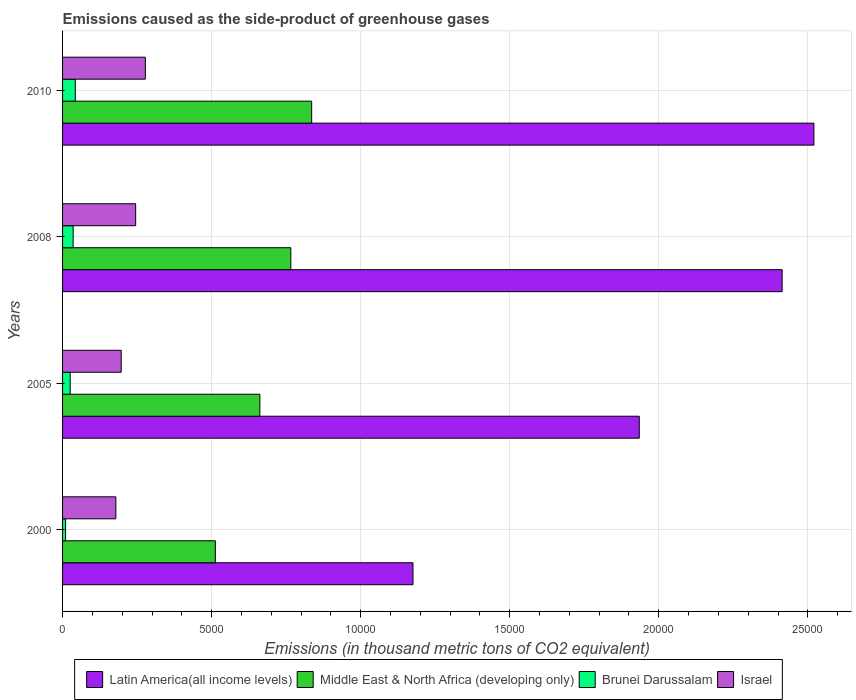Are the number of bars per tick equal to the number of legend labels?
Your answer should be compact. Yes. Are the number of bars on each tick of the Y-axis equal?
Your answer should be very brief. Yes. How many bars are there on the 3rd tick from the bottom?
Offer a very short reply. 4. What is the label of the 3rd group of bars from the top?
Offer a very short reply. 2005. What is the emissions caused as the side-product of greenhouse gases in Brunei Darussalam in 2005?
Keep it short and to the point. 255.6. Across all years, what is the maximum emissions caused as the side-product of greenhouse gases in Middle East & North Africa (developing only)?
Provide a succinct answer. 8356. Across all years, what is the minimum emissions caused as the side-product of greenhouse gases in Israel?
Your answer should be compact. 1787.6. In which year was the emissions caused as the side-product of greenhouse gases in Middle East & North Africa (developing only) maximum?
Provide a succinct answer. 2010. What is the total emissions caused as the side-product of greenhouse gases in Latin America(all income levels) in the graph?
Offer a terse response. 8.04e+04. What is the difference between the emissions caused as the side-product of greenhouse gases in Latin America(all income levels) in 2000 and that in 2010?
Give a very brief answer. -1.34e+04. What is the difference between the emissions caused as the side-product of greenhouse gases in Middle East & North Africa (developing only) in 2000 and the emissions caused as the side-product of greenhouse gases in Latin America(all income levels) in 2008?
Make the answer very short. -1.90e+04. What is the average emissions caused as the side-product of greenhouse gases in Israel per year?
Provide a short and direct response. 2246.03. In the year 2008, what is the difference between the emissions caused as the side-product of greenhouse gases in Israel and emissions caused as the side-product of greenhouse gases in Middle East & North Africa (developing only)?
Offer a terse response. -5205.1. What is the ratio of the emissions caused as the side-product of greenhouse gases in Latin America(all income levels) in 2005 to that in 2008?
Your response must be concise. 0.8. Is the emissions caused as the side-product of greenhouse gases in Latin America(all income levels) in 2005 less than that in 2010?
Provide a short and direct response. Yes. What is the difference between the highest and the second highest emissions caused as the side-product of greenhouse gases in Brunei Darussalam?
Ensure brevity in your answer.  72.1. What is the difference between the highest and the lowest emissions caused as the side-product of greenhouse gases in Latin America(all income levels)?
Your answer should be compact. 1.34e+04. Is the sum of the emissions caused as the side-product of greenhouse gases in Middle East & North Africa (developing only) in 2008 and 2010 greater than the maximum emissions caused as the side-product of greenhouse gases in Latin America(all income levels) across all years?
Give a very brief answer. No. What does the 4th bar from the top in 2008 represents?
Your answer should be compact. Latin America(all income levels). What does the 2nd bar from the bottom in 2008 represents?
Make the answer very short. Middle East & North Africa (developing only). Is it the case that in every year, the sum of the emissions caused as the side-product of greenhouse gases in Brunei Darussalam and emissions caused as the side-product of greenhouse gases in Israel is greater than the emissions caused as the side-product of greenhouse gases in Middle East & North Africa (developing only)?
Your answer should be compact. No. Are all the bars in the graph horizontal?
Provide a succinct answer. Yes. What is the difference between two consecutive major ticks on the X-axis?
Make the answer very short. 5000. Are the values on the major ticks of X-axis written in scientific E-notation?
Make the answer very short. No. How many legend labels are there?
Provide a short and direct response. 4. How are the legend labels stacked?
Your answer should be very brief. Horizontal. What is the title of the graph?
Your response must be concise. Emissions caused as the side-product of greenhouse gases. What is the label or title of the X-axis?
Ensure brevity in your answer.  Emissions (in thousand metric tons of CO2 equivalent). What is the label or title of the Y-axis?
Your answer should be compact. Years. What is the Emissions (in thousand metric tons of CO2 equivalent) of Latin America(all income levels) in 2000?
Give a very brief answer. 1.18e+04. What is the Emissions (in thousand metric tons of CO2 equivalent) in Middle East & North Africa (developing only) in 2000?
Offer a very short reply. 5124.9. What is the Emissions (in thousand metric tons of CO2 equivalent) of Brunei Darussalam in 2000?
Provide a succinct answer. 100.7. What is the Emissions (in thousand metric tons of CO2 equivalent) in Israel in 2000?
Keep it short and to the point. 1787.6. What is the Emissions (in thousand metric tons of CO2 equivalent) of Latin America(all income levels) in 2005?
Provide a short and direct response. 1.93e+04. What is the Emissions (in thousand metric tons of CO2 equivalent) in Middle East & North Africa (developing only) in 2005?
Provide a succinct answer. 6617.8. What is the Emissions (in thousand metric tons of CO2 equivalent) of Brunei Darussalam in 2005?
Keep it short and to the point. 255.6. What is the Emissions (in thousand metric tons of CO2 equivalent) of Israel in 2005?
Your response must be concise. 1967.4. What is the Emissions (in thousand metric tons of CO2 equivalent) in Latin America(all income levels) in 2008?
Your answer should be compact. 2.41e+04. What is the Emissions (in thousand metric tons of CO2 equivalent) in Middle East & North Africa (developing only) in 2008?
Make the answer very short. 7657.2. What is the Emissions (in thousand metric tons of CO2 equivalent) in Brunei Darussalam in 2008?
Your response must be concise. 354.9. What is the Emissions (in thousand metric tons of CO2 equivalent) in Israel in 2008?
Keep it short and to the point. 2452.1. What is the Emissions (in thousand metric tons of CO2 equivalent) in Latin America(all income levels) in 2010?
Provide a short and direct response. 2.52e+04. What is the Emissions (in thousand metric tons of CO2 equivalent) of Middle East & North Africa (developing only) in 2010?
Your answer should be very brief. 8356. What is the Emissions (in thousand metric tons of CO2 equivalent) in Brunei Darussalam in 2010?
Offer a terse response. 427. What is the Emissions (in thousand metric tons of CO2 equivalent) of Israel in 2010?
Ensure brevity in your answer.  2777. Across all years, what is the maximum Emissions (in thousand metric tons of CO2 equivalent) of Latin America(all income levels)?
Give a very brief answer. 2.52e+04. Across all years, what is the maximum Emissions (in thousand metric tons of CO2 equivalent) of Middle East & North Africa (developing only)?
Offer a very short reply. 8356. Across all years, what is the maximum Emissions (in thousand metric tons of CO2 equivalent) of Brunei Darussalam?
Your answer should be very brief. 427. Across all years, what is the maximum Emissions (in thousand metric tons of CO2 equivalent) of Israel?
Ensure brevity in your answer.  2777. Across all years, what is the minimum Emissions (in thousand metric tons of CO2 equivalent) in Latin America(all income levels)?
Your answer should be compact. 1.18e+04. Across all years, what is the minimum Emissions (in thousand metric tons of CO2 equivalent) of Middle East & North Africa (developing only)?
Your response must be concise. 5124.9. Across all years, what is the minimum Emissions (in thousand metric tons of CO2 equivalent) of Brunei Darussalam?
Make the answer very short. 100.7. Across all years, what is the minimum Emissions (in thousand metric tons of CO2 equivalent) in Israel?
Your answer should be very brief. 1787.6. What is the total Emissions (in thousand metric tons of CO2 equivalent) of Latin America(all income levels) in the graph?
Provide a short and direct response. 8.04e+04. What is the total Emissions (in thousand metric tons of CO2 equivalent) of Middle East & North Africa (developing only) in the graph?
Offer a terse response. 2.78e+04. What is the total Emissions (in thousand metric tons of CO2 equivalent) in Brunei Darussalam in the graph?
Make the answer very short. 1138.2. What is the total Emissions (in thousand metric tons of CO2 equivalent) of Israel in the graph?
Keep it short and to the point. 8984.1. What is the difference between the Emissions (in thousand metric tons of CO2 equivalent) in Latin America(all income levels) in 2000 and that in 2005?
Provide a succinct answer. -7590.8. What is the difference between the Emissions (in thousand metric tons of CO2 equivalent) of Middle East & North Africa (developing only) in 2000 and that in 2005?
Your answer should be very brief. -1492.9. What is the difference between the Emissions (in thousand metric tons of CO2 equivalent) in Brunei Darussalam in 2000 and that in 2005?
Make the answer very short. -154.9. What is the difference between the Emissions (in thousand metric tons of CO2 equivalent) of Israel in 2000 and that in 2005?
Your answer should be compact. -179.8. What is the difference between the Emissions (in thousand metric tons of CO2 equivalent) of Latin America(all income levels) in 2000 and that in 2008?
Provide a succinct answer. -1.24e+04. What is the difference between the Emissions (in thousand metric tons of CO2 equivalent) in Middle East & North Africa (developing only) in 2000 and that in 2008?
Offer a terse response. -2532.3. What is the difference between the Emissions (in thousand metric tons of CO2 equivalent) in Brunei Darussalam in 2000 and that in 2008?
Offer a terse response. -254.2. What is the difference between the Emissions (in thousand metric tons of CO2 equivalent) in Israel in 2000 and that in 2008?
Keep it short and to the point. -664.5. What is the difference between the Emissions (in thousand metric tons of CO2 equivalent) of Latin America(all income levels) in 2000 and that in 2010?
Your answer should be very brief. -1.34e+04. What is the difference between the Emissions (in thousand metric tons of CO2 equivalent) in Middle East & North Africa (developing only) in 2000 and that in 2010?
Make the answer very short. -3231.1. What is the difference between the Emissions (in thousand metric tons of CO2 equivalent) of Brunei Darussalam in 2000 and that in 2010?
Your response must be concise. -326.3. What is the difference between the Emissions (in thousand metric tons of CO2 equivalent) in Israel in 2000 and that in 2010?
Give a very brief answer. -989.4. What is the difference between the Emissions (in thousand metric tons of CO2 equivalent) of Latin America(all income levels) in 2005 and that in 2008?
Offer a terse response. -4793.3. What is the difference between the Emissions (in thousand metric tons of CO2 equivalent) of Middle East & North Africa (developing only) in 2005 and that in 2008?
Make the answer very short. -1039.4. What is the difference between the Emissions (in thousand metric tons of CO2 equivalent) in Brunei Darussalam in 2005 and that in 2008?
Your answer should be very brief. -99.3. What is the difference between the Emissions (in thousand metric tons of CO2 equivalent) of Israel in 2005 and that in 2008?
Your response must be concise. -484.7. What is the difference between the Emissions (in thousand metric tons of CO2 equivalent) of Latin America(all income levels) in 2005 and that in 2010?
Give a very brief answer. -5858.9. What is the difference between the Emissions (in thousand metric tons of CO2 equivalent) in Middle East & North Africa (developing only) in 2005 and that in 2010?
Your answer should be compact. -1738.2. What is the difference between the Emissions (in thousand metric tons of CO2 equivalent) of Brunei Darussalam in 2005 and that in 2010?
Give a very brief answer. -171.4. What is the difference between the Emissions (in thousand metric tons of CO2 equivalent) in Israel in 2005 and that in 2010?
Give a very brief answer. -809.6. What is the difference between the Emissions (in thousand metric tons of CO2 equivalent) in Latin America(all income levels) in 2008 and that in 2010?
Your response must be concise. -1065.6. What is the difference between the Emissions (in thousand metric tons of CO2 equivalent) in Middle East & North Africa (developing only) in 2008 and that in 2010?
Provide a short and direct response. -698.8. What is the difference between the Emissions (in thousand metric tons of CO2 equivalent) of Brunei Darussalam in 2008 and that in 2010?
Ensure brevity in your answer.  -72.1. What is the difference between the Emissions (in thousand metric tons of CO2 equivalent) in Israel in 2008 and that in 2010?
Give a very brief answer. -324.9. What is the difference between the Emissions (in thousand metric tons of CO2 equivalent) of Latin America(all income levels) in 2000 and the Emissions (in thousand metric tons of CO2 equivalent) of Middle East & North Africa (developing only) in 2005?
Provide a short and direct response. 5137.5. What is the difference between the Emissions (in thousand metric tons of CO2 equivalent) in Latin America(all income levels) in 2000 and the Emissions (in thousand metric tons of CO2 equivalent) in Brunei Darussalam in 2005?
Offer a terse response. 1.15e+04. What is the difference between the Emissions (in thousand metric tons of CO2 equivalent) in Latin America(all income levels) in 2000 and the Emissions (in thousand metric tons of CO2 equivalent) in Israel in 2005?
Keep it short and to the point. 9787.9. What is the difference between the Emissions (in thousand metric tons of CO2 equivalent) in Middle East & North Africa (developing only) in 2000 and the Emissions (in thousand metric tons of CO2 equivalent) in Brunei Darussalam in 2005?
Make the answer very short. 4869.3. What is the difference between the Emissions (in thousand metric tons of CO2 equivalent) in Middle East & North Africa (developing only) in 2000 and the Emissions (in thousand metric tons of CO2 equivalent) in Israel in 2005?
Keep it short and to the point. 3157.5. What is the difference between the Emissions (in thousand metric tons of CO2 equivalent) in Brunei Darussalam in 2000 and the Emissions (in thousand metric tons of CO2 equivalent) in Israel in 2005?
Offer a terse response. -1866.7. What is the difference between the Emissions (in thousand metric tons of CO2 equivalent) in Latin America(all income levels) in 2000 and the Emissions (in thousand metric tons of CO2 equivalent) in Middle East & North Africa (developing only) in 2008?
Your answer should be compact. 4098.1. What is the difference between the Emissions (in thousand metric tons of CO2 equivalent) in Latin America(all income levels) in 2000 and the Emissions (in thousand metric tons of CO2 equivalent) in Brunei Darussalam in 2008?
Provide a succinct answer. 1.14e+04. What is the difference between the Emissions (in thousand metric tons of CO2 equivalent) in Latin America(all income levels) in 2000 and the Emissions (in thousand metric tons of CO2 equivalent) in Israel in 2008?
Your answer should be compact. 9303.2. What is the difference between the Emissions (in thousand metric tons of CO2 equivalent) in Middle East & North Africa (developing only) in 2000 and the Emissions (in thousand metric tons of CO2 equivalent) in Brunei Darussalam in 2008?
Provide a short and direct response. 4770. What is the difference between the Emissions (in thousand metric tons of CO2 equivalent) of Middle East & North Africa (developing only) in 2000 and the Emissions (in thousand metric tons of CO2 equivalent) of Israel in 2008?
Give a very brief answer. 2672.8. What is the difference between the Emissions (in thousand metric tons of CO2 equivalent) in Brunei Darussalam in 2000 and the Emissions (in thousand metric tons of CO2 equivalent) in Israel in 2008?
Ensure brevity in your answer.  -2351.4. What is the difference between the Emissions (in thousand metric tons of CO2 equivalent) of Latin America(all income levels) in 2000 and the Emissions (in thousand metric tons of CO2 equivalent) of Middle East & North Africa (developing only) in 2010?
Your answer should be compact. 3399.3. What is the difference between the Emissions (in thousand metric tons of CO2 equivalent) of Latin America(all income levels) in 2000 and the Emissions (in thousand metric tons of CO2 equivalent) of Brunei Darussalam in 2010?
Offer a very short reply. 1.13e+04. What is the difference between the Emissions (in thousand metric tons of CO2 equivalent) of Latin America(all income levels) in 2000 and the Emissions (in thousand metric tons of CO2 equivalent) of Israel in 2010?
Offer a very short reply. 8978.3. What is the difference between the Emissions (in thousand metric tons of CO2 equivalent) in Middle East & North Africa (developing only) in 2000 and the Emissions (in thousand metric tons of CO2 equivalent) in Brunei Darussalam in 2010?
Make the answer very short. 4697.9. What is the difference between the Emissions (in thousand metric tons of CO2 equivalent) of Middle East & North Africa (developing only) in 2000 and the Emissions (in thousand metric tons of CO2 equivalent) of Israel in 2010?
Your answer should be very brief. 2347.9. What is the difference between the Emissions (in thousand metric tons of CO2 equivalent) of Brunei Darussalam in 2000 and the Emissions (in thousand metric tons of CO2 equivalent) of Israel in 2010?
Offer a terse response. -2676.3. What is the difference between the Emissions (in thousand metric tons of CO2 equivalent) of Latin America(all income levels) in 2005 and the Emissions (in thousand metric tons of CO2 equivalent) of Middle East & North Africa (developing only) in 2008?
Ensure brevity in your answer.  1.17e+04. What is the difference between the Emissions (in thousand metric tons of CO2 equivalent) in Latin America(all income levels) in 2005 and the Emissions (in thousand metric tons of CO2 equivalent) in Brunei Darussalam in 2008?
Your answer should be compact. 1.90e+04. What is the difference between the Emissions (in thousand metric tons of CO2 equivalent) in Latin America(all income levels) in 2005 and the Emissions (in thousand metric tons of CO2 equivalent) in Israel in 2008?
Your response must be concise. 1.69e+04. What is the difference between the Emissions (in thousand metric tons of CO2 equivalent) of Middle East & North Africa (developing only) in 2005 and the Emissions (in thousand metric tons of CO2 equivalent) of Brunei Darussalam in 2008?
Your answer should be very brief. 6262.9. What is the difference between the Emissions (in thousand metric tons of CO2 equivalent) in Middle East & North Africa (developing only) in 2005 and the Emissions (in thousand metric tons of CO2 equivalent) in Israel in 2008?
Your answer should be very brief. 4165.7. What is the difference between the Emissions (in thousand metric tons of CO2 equivalent) of Brunei Darussalam in 2005 and the Emissions (in thousand metric tons of CO2 equivalent) of Israel in 2008?
Make the answer very short. -2196.5. What is the difference between the Emissions (in thousand metric tons of CO2 equivalent) in Latin America(all income levels) in 2005 and the Emissions (in thousand metric tons of CO2 equivalent) in Middle East & North Africa (developing only) in 2010?
Your answer should be very brief. 1.10e+04. What is the difference between the Emissions (in thousand metric tons of CO2 equivalent) in Latin America(all income levels) in 2005 and the Emissions (in thousand metric tons of CO2 equivalent) in Brunei Darussalam in 2010?
Offer a very short reply. 1.89e+04. What is the difference between the Emissions (in thousand metric tons of CO2 equivalent) of Latin America(all income levels) in 2005 and the Emissions (in thousand metric tons of CO2 equivalent) of Israel in 2010?
Keep it short and to the point. 1.66e+04. What is the difference between the Emissions (in thousand metric tons of CO2 equivalent) of Middle East & North Africa (developing only) in 2005 and the Emissions (in thousand metric tons of CO2 equivalent) of Brunei Darussalam in 2010?
Provide a short and direct response. 6190.8. What is the difference between the Emissions (in thousand metric tons of CO2 equivalent) of Middle East & North Africa (developing only) in 2005 and the Emissions (in thousand metric tons of CO2 equivalent) of Israel in 2010?
Make the answer very short. 3840.8. What is the difference between the Emissions (in thousand metric tons of CO2 equivalent) in Brunei Darussalam in 2005 and the Emissions (in thousand metric tons of CO2 equivalent) in Israel in 2010?
Give a very brief answer. -2521.4. What is the difference between the Emissions (in thousand metric tons of CO2 equivalent) in Latin America(all income levels) in 2008 and the Emissions (in thousand metric tons of CO2 equivalent) in Middle East & North Africa (developing only) in 2010?
Give a very brief answer. 1.58e+04. What is the difference between the Emissions (in thousand metric tons of CO2 equivalent) of Latin America(all income levels) in 2008 and the Emissions (in thousand metric tons of CO2 equivalent) of Brunei Darussalam in 2010?
Offer a very short reply. 2.37e+04. What is the difference between the Emissions (in thousand metric tons of CO2 equivalent) in Latin America(all income levels) in 2008 and the Emissions (in thousand metric tons of CO2 equivalent) in Israel in 2010?
Ensure brevity in your answer.  2.14e+04. What is the difference between the Emissions (in thousand metric tons of CO2 equivalent) of Middle East & North Africa (developing only) in 2008 and the Emissions (in thousand metric tons of CO2 equivalent) of Brunei Darussalam in 2010?
Your response must be concise. 7230.2. What is the difference between the Emissions (in thousand metric tons of CO2 equivalent) in Middle East & North Africa (developing only) in 2008 and the Emissions (in thousand metric tons of CO2 equivalent) in Israel in 2010?
Provide a short and direct response. 4880.2. What is the difference between the Emissions (in thousand metric tons of CO2 equivalent) of Brunei Darussalam in 2008 and the Emissions (in thousand metric tons of CO2 equivalent) of Israel in 2010?
Your response must be concise. -2422.1. What is the average Emissions (in thousand metric tons of CO2 equivalent) in Latin America(all income levels) per year?
Keep it short and to the point. 2.01e+04. What is the average Emissions (in thousand metric tons of CO2 equivalent) in Middle East & North Africa (developing only) per year?
Offer a very short reply. 6938.98. What is the average Emissions (in thousand metric tons of CO2 equivalent) of Brunei Darussalam per year?
Provide a short and direct response. 284.55. What is the average Emissions (in thousand metric tons of CO2 equivalent) in Israel per year?
Ensure brevity in your answer.  2246.03. In the year 2000, what is the difference between the Emissions (in thousand metric tons of CO2 equivalent) of Latin America(all income levels) and Emissions (in thousand metric tons of CO2 equivalent) of Middle East & North Africa (developing only)?
Make the answer very short. 6630.4. In the year 2000, what is the difference between the Emissions (in thousand metric tons of CO2 equivalent) in Latin America(all income levels) and Emissions (in thousand metric tons of CO2 equivalent) in Brunei Darussalam?
Offer a very short reply. 1.17e+04. In the year 2000, what is the difference between the Emissions (in thousand metric tons of CO2 equivalent) in Latin America(all income levels) and Emissions (in thousand metric tons of CO2 equivalent) in Israel?
Make the answer very short. 9967.7. In the year 2000, what is the difference between the Emissions (in thousand metric tons of CO2 equivalent) in Middle East & North Africa (developing only) and Emissions (in thousand metric tons of CO2 equivalent) in Brunei Darussalam?
Offer a very short reply. 5024.2. In the year 2000, what is the difference between the Emissions (in thousand metric tons of CO2 equivalent) of Middle East & North Africa (developing only) and Emissions (in thousand metric tons of CO2 equivalent) of Israel?
Your response must be concise. 3337.3. In the year 2000, what is the difference between the Emissions (in thousand metric tons of CO2 equivalent) in Brunei Darussalam and Emissions (in thousand metric tons of CO2 equivalent) in Israel?
Your answer should be very brief. -1686.9. In the year 2005, what is the difference between the Emissions (in thousand metric tons of CO2 equivalent) of Latin America(all income levels) and Emissions (in thousand metric tons of CO2 equivalent) of Middle East & North Africa (developing only)?
Keep it short and to the point. 1.27e+04. In the year 2005, what is the difference between the Emissions (in thousand metric tons of CO2 equivalent) in Latin America(all income levels) and Emissions (in thousand metric tons of CO2 equivalent) in Brunei Darussalam?
Ensure brevity in your answer.  1.91e+04. In the year 2005, what is the difference between the Emissions (in thousand metric tons of CO2 equivalent) in Latin America(all income levels) and Emissions (in thousand metric tons of CO2 equivalent) in Israel?
Offer a terse response. 1.74e+04. In the year 2005, what is the difference between the Emissions (in thousand metric tons of CO2 equivalent) in Middle East & North Africa (developing only) and Emissions (in thousand metric tons of CO2 equivalent) in Brunei Darussalam?
Ensure brevity in your answer.  6362.2. In the year 2005, what is the difference between the Emissions (in thousand metric tons of CO2 equivalent) of Middle East & North Africa (developing only) and Emissions (in thousand metric tons of CO2 equivalent) of Israel?
Ensure brevity in your answer.  4650.4. In the year 2005, what is the difference between the Emissions (in thousand metric tons of CO2 equivalent) of Brunei Darussalam and Emissions (in thousand metric tons of CO2 equivalent) of Israel?
Provide a succinct answer. -1711.8. In the year 2008, what is the difference between the Emissions (in thousand metric tons of CO2 equivalent) in Latin America(all income levels) and Emissions (in thousand metric tons of CO2 equivalent) in Middle East & North Africa (developing only)?
Keep it short and to the point. 1.65e+04. In the year 2008, what is the difference between the Emissions (in thousand metric tons of CO2 equivalent) in Latin America(all income levels) and Emissions (in thousand metric tons of CO2 equivalent) in Brunei Darussalam?
Provide a succinct answer. 2.38e+04. In the year 2008, what is the difference between the Emissions (in thousand metric tons of CO2 equivalent) in Latin America(all income levels) and Emissions (in thousand metric tons of CO2 equivalent) in Israel?
Your answer should be very brief. 2.17e+04. In the year 2008, what is the difference between the Emissions (in thousand metric tons of CO2 equivalent) of Middle East & North Africa (developing only) and Emissions (in thousand metric tons of CO2 equivalent) of Brunei Darussalam?
Ensure brevity in your answer.  7302.3. In the year 2008, what is the difference between the Emissions (in thousand metric tons of CO2 equivalent) of Middle East & North Africa (developing only) and Emissions (in thousand metric tons of CO2 equivalent) of Israel?
Make the answer very short. 5205.1. In the year 2008, what is the difference between the Emissions (in thousand metric tons of CO2 equivalent) of Brunei Darussalam and Emissions (in thousand metric tons of CO2 equivalent) of Israel?
Keep it short and to the point. -2097.2. In the year 2010, what is the difference between the Emissions (in thousand metric tons of CO2 equivalent) in Latin America(all income levels) and Emissions (in thousand metric tons of CO2 equivalent) in Middle East & North Africa (developing only)?
Ensure brevity in your answer.  1.68e+04. In the year 2010, what is the difference between the Emissions (in thousand metric tons of CO2 equivalent) in Latin America(all income levels) and Emissions (in thousand metric tons of CO2 equivalent) in Brunei Darussalam?
Give a very brief answer. 2.48e+04. In the year 2010, what is the difference between the Emissions (in thousand metric tons of CO2 equivalent) of Latin America(all income levels) and Emissions (in thousand metric tons of CO2 equivalent) of Israel?
Offer a very short reply. 2.24e+04. In the year 2010, what is the difference between the Emissions (in thousand metric tons of CO2 equivalent) of Middle East & North Africa (developing only) and Emissions (in thousand metric tons of CO2 equivalent) of Brunei Darussalam?
Ensure brevity in your answer.  7929. In the year 2010, what is the difference between the Emissions (in thousand metric tons of CO2 equivalent) in Middle East & North Africa (developing only) and Emissions (in thousand metric tons of CO2 equivalent) in Israel?
Your answer should be very brief. 5579. In the year 2010, what is the difference between the Emissions (in thousand metric tons of CO2 equivalent) in Brunei Darussalam and Emissions (in thousand metric tons of CO2 equivalent) in Israel?
Your response must be concise. -2350. What is the ratio of the Emissions (in thousand metric tons of CO2 equivalent) of Latin America(all income levels) in 2000 to that in 2005?
Provide a succinct answer. 0.61. What is the ratio of the Emissions (in thousand metric tons of CO2 equivalent) in Middle East & North Africa (developing only) in 2000 to that in 2005?
Your answer should be compact. 0.77. What is the ratio of the Emissions (in thousand metric tons of CO2 equivalent) in Brunei Darussalam in 2000 to that in 2005?
Offer a very short reply. 0.39. What is the ratio of the Emissions (in thousand metric tons of CO2 equivalent) in Israel in 2000 to that in 2005?
Provide a short and direct response. 0.91. What is the ratio of the Emissions (in thousand metric tons of CO2 equivalent) of Latin America(all income levels) in 2000 to that in 2008?
Give a very brief answer. 0.49. What is the ratio of the Emissions (in thousand metric tons of CO2 equivalent) in Middle East & North Africa (developing only) in 2000 to that in 2008?
Offer a terse response. 0.67. What is the ratio of the Emissions (in thousand metric tons of CO2 equivalent) in Brunei Darussalam in 2000 to that in 2008?
Provide a succinct answer. 0.28. What is the ratio of the Emissions (in thousand metric tons of CO2 equivalent) in Israel in 2000 to that in 2008?
Your answer should be very brief. 0.73. What is the ratio of the Emissions (in thousand metric tons of CO2 equivalent) in Latin America(all income levels) in 2000 to that in 2010?
Give a very brief answer. 0.47. What is the ratio of the Emissions (in thousand metric tons of CO2 equivalent) in Middle East & North Africa (developing only) in 2000 to that in 2010?
Give a very brief answer. 0.61. What is the ratio of the Emissions (in thousand metric tons of CO2 equivalent) in Brunei Darussalam in 2000 to that in 2010?
Your response must be concise. 0.24. What is the ratio of the Emissions (in thousand metric tons of CO2 equivalent) of Israel in 2000 to that in 2010?
Provide a short and direct response. 0.64. What is the ratio of the Emissions (in thousand metric tons of CO2 equivalent) of Latin America(all income levels) in 2005 to that in 2008?
Keep it short and to the point. 0.8. What is the ratio of the Emissions (in thousand metric tons of CO2 equivalent) of Middle East & North Africa (developing only) in 2005 to that in 2008?
Give a very brief answer. 0.86. What is the ratio of the Emissions (in thousand metric tons of CO2 equivalent) in Brunei Darussalam in 2005 to that in 2008?
Ensure brevity in your answer.  0.72. What is the ratio of the Emissions (in thousand metric tons of CO2 equivalent) of Israel in 2005 to that in 2008?
Ensure brevity in your answer.  0.8. What is the ratio of the Emissions (in thousand metric tons of CO2 equivalent) in Latin America(all income levels) in 2005 to that in 2010?
Give a very brief answer. 0.77. What is the ratio of the Emissions (in thousand metric tons of CO2 equivalent) in Middle East & North Africa (developing only) in 2005 to that in 2010?
Provide a succinct answer. 0.79. What is the ratio of the Emissions (in thousand metric tons of CO2 equivalent) of Brunei Darussalam in 2005 to that in 2010?
Your answer should be compact. 0.6. What is the ratio of the Emissions (in thousand metric tons of CO2 equivalent) of Israel in 2005 to that in 2010?
Ensure brevity in your answer.  0.71. What is the ratio of the Emissions (in thousand metric tons of CO2 equivalent) in Latin America(all income levels) in 2008 to that in 2010?
Provide a short and direct response. 0.96. What is the ratio of the Emissions (in thousand metric tons of CO2 equivalent) of Middle East & North Africa (developing only) in 2008 to that in 2010?
Your answer should be very brief. 0.92. What is the ratio of the Emissions (in thousand metric tons of CO2 equivalent) in Brunei Darussalam in 2008 to that in 2010?
Provide a short and direct response. 0.83. What is the ratio of the Emissions (in thousand metric tons of CO2 equivalent) in Israel in 2008 to that in 2010?
Your answer should be compact. 0.88. What is the difference between the highest and the second highest Emissions (in thousand metric tons of CO2 equivalent) of Latin America(all income levels)?
Your response must be concise. 1065.6. What is the difference between the highest and the second highest Emissions (in thousand metric tons of CO2 equivalent) in Middle East & North Africa (developing only)?
Make the answer very short. 698.8. What is the difference between the highest and the second highest Emissions (in thousand metric tons of CO2 equivalent) of Brunei Darussalam?
Provide a short and direct response. 72.1. What is the difference between the highest and the second highest Emissions (in thousand metric tons of CO2 equivalent) of Israel?
Ensure brevity in your answer.  324.9. What is the difference between the highest and the lowest Emissions (in thousand metric tons of CO2 equivalent) in Latin America(all income levels)?
Ensure brevity in your answer.  1.34e+04. What is the difference between the highest and the lowest Emissions (in thousand metric tons of CO2 equivalent) in Middle East & North Africa (developing only)?
Offer a very short reply. 3231.1. What is the difference between the highest and the lowest Emissions (in thousand metric tons of CO2 equivalent) of Brunei Darussalam?
Your answer should be very brief. 326.3. What is the difference between the highest and the lowest Emissions (in thousand metric tons of CO2 equivalent) in Israel?
Ensure brevity in your answer.  989.4. 